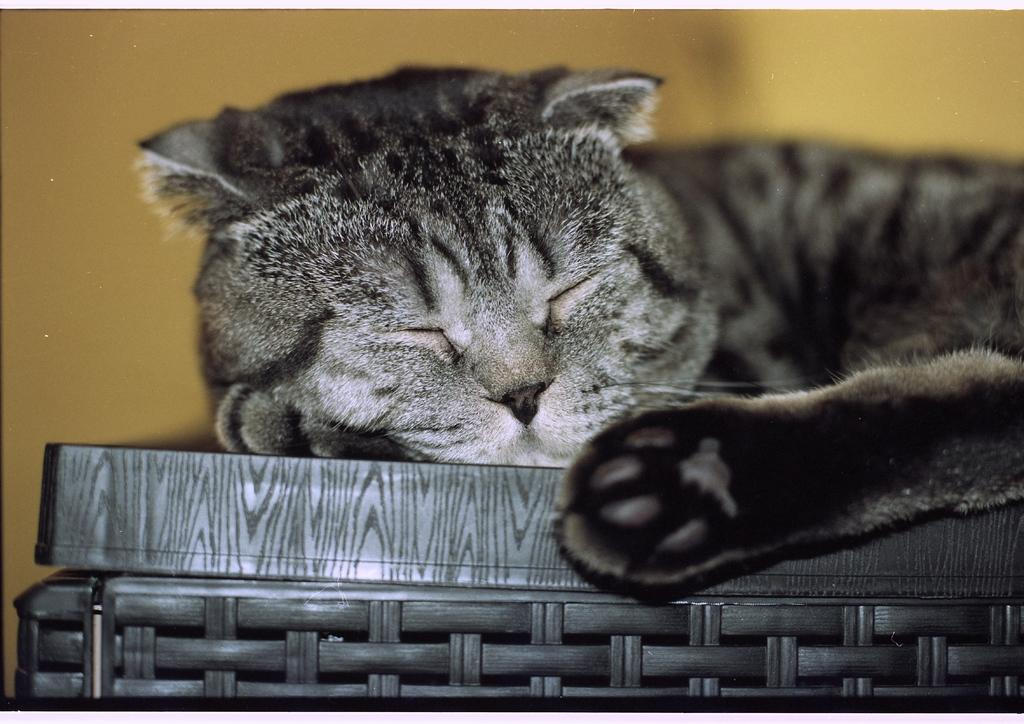What type of animal is in the image? There is a cat in the image. What is the cat doing in the image? The cat is laying on a basket. What type of jam is being produced at the plantation in the image? There is no plantation or jam production present in the image; it features a cat laying on a basket. What type of iron is visible in the image? There is no iron present in the image. 